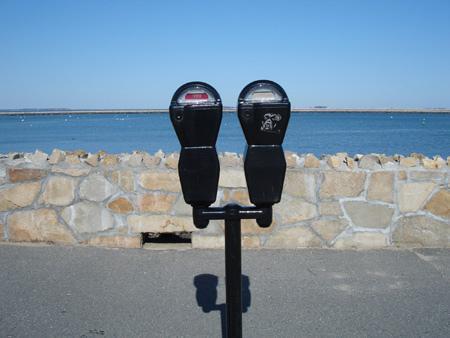How many parking meters can be seen?
Give a very brief answer. 2. How many bears are wearing blue?
Give a very brief answer. 0. 